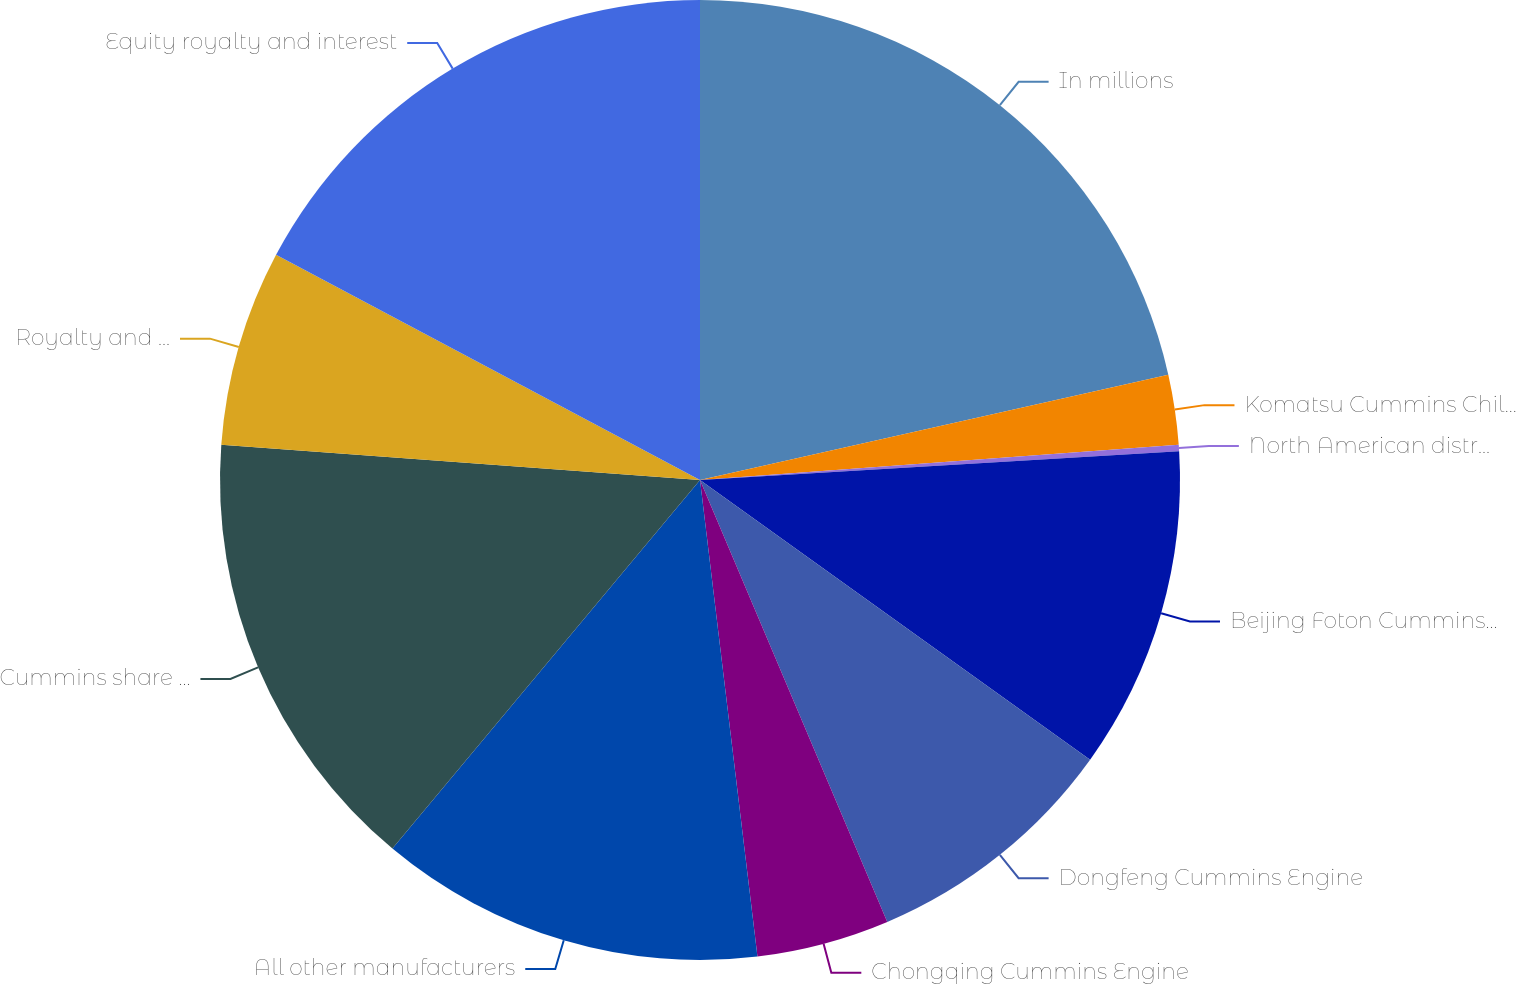Convert chart to OTSL. <chart><loc_0><loc_0><loc_500><loc_500><pie_chart><fcel>In millions<fcel>Komatsu Cummins Chile Ltda<fcel>North American distributors<fcel>Beijing Foton Cummins Engine<fcel>Dongfeng Cummins Engine<fcel>Chongqing Cummins Engine<fcel>All other manufacturers<fcel>Cummins share of net income<fcel>Royalty and interest income<fcel>Equity royalty and interest<nl><fcel>21.48%<fcel>2.35%<fcel>0.22%<fcel>10.85%<fcel>8.72%<fcel>4.47%<fcel>12.98%<fcel>15.1%<fcel>6.6%<fcel>17.23%<nl></chart> 